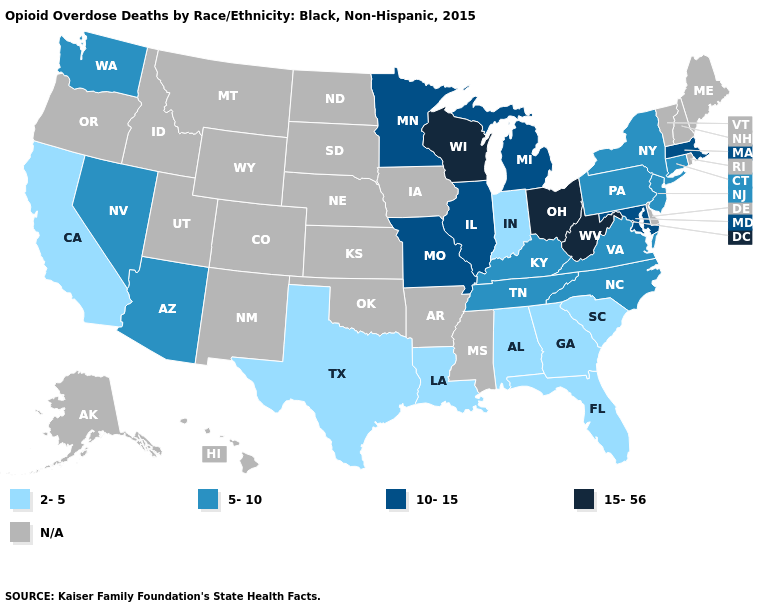Does the first symbol in the legend represent the smallest category?
Write a very short answer. Yes. What is the value of Wisconsin?
Quick response, please. 15-56. Name the states that have a value in the range 5-10?
Short answer required. Arizona, Connecticut, Kentucky, Nevada, New Jersey, New York, North Carolina, Pennsylvania, Tennessee, Virginia, Washington. What is the lowest value in states that border Mississippi?
Short answer required. 2-5. Among the states that border Texas , which have the lowest value?
Give a very brief answer. Louisiana. Which states hav the highest value in the South?
Be succinct. West Virginia. Among the states that border Iowa , which have the lowest value?
Answer briefly. Illinois, Minnesota, Missouri. Does California have the highest value in the USA?
Concise answer only. No. Name the states that have a value in the range 5-10?
Keep it brief. Arizona, Connecticut, Kentucky, Nevada, New Jersey, New York, North Carolina, Pennsylvania, Tennessee, Virginia, Washington. What is the lowest value in the Northeast?
Quick response, please. 5-10. Name the states that have a value in the range N/A?
Quick response, please. Alaska, Arkansas, Colorado, Delaware, Hawaii, Idaho, Iowa, Kansas, Maine, Mississippi, Montana, Nebraska, New Hampshire, New Mexico, North Dakota, Oklahoma, Oregon, Rhode Island, South Dakota, Utah, Vermont, Wyoming. What is the value of Indiana?
Quick response, please. 2-5. Which states hav the highest value in the South?
Answer briefly. West Virginia. 